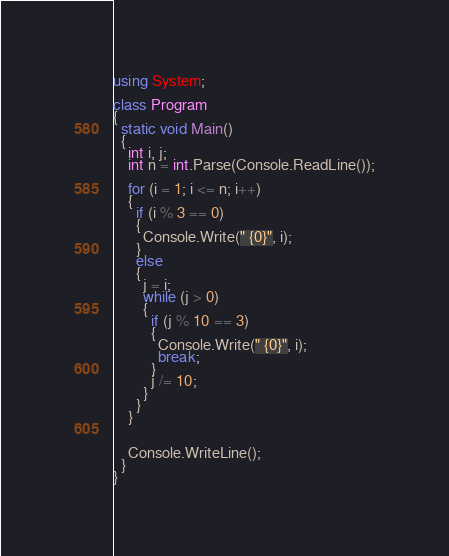<code> <loc_0><loc_0><loc_500><loc_500><_C#_>using System;

class Program
{
  static void Main()
  {
    int i, j;
    int n = int.Parse(Console.ReadLine());

    for (i = 1; i <= n; i++)
    {
      if (i % 3 == 0)
      {
        Console.Write(" {0}", i);
      }
      else
      {
        j = i;
        while (j > 0)
        {
          if (j % 10 == 3)
          {
            Console.Write(" {0}", i);
            break;
          }
          j /= 10;
        }
      }
    }


    Console.WriteLine();
  }
}</code> 